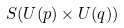<formula> <loc_0><loc_0><loc_500><loc_500>S ( U ( p ) \times U ( q ) )</formula> 